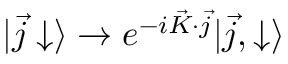<formula> <loc_0><loc_0><loc_500><loc_500>| \vec { j } \downarrow \rangle \rightarrow e ^ { - i \vec { K } \cdot \vec { j } } | \vec { j } , \downarrow \rangle</formula> 